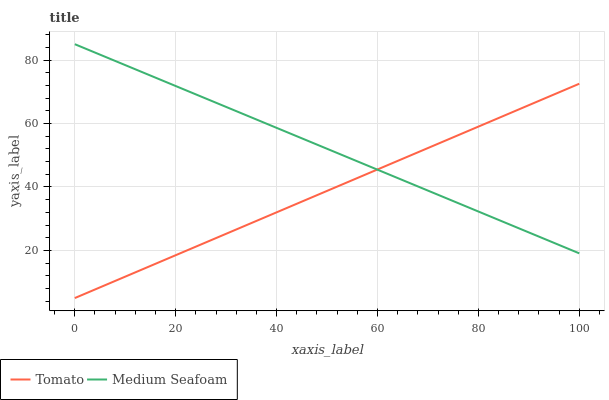Does Tomato have the minimum area under the curve?
Answer yes or no. Yes. Does Medium Seafoam have the maximum area under the curve?
Answer yes or no. Yes. Does Medium Seafoam have the minimum area under the curve?
Answer yes or no. No. Is Tomato the smoothest?
Answer yes or no. Yes. Is Medium Seafoam the roughest?
Answer yes or no. Yes. Is Medium Seafoam the smoothest?
Answer yes or no. No. Does Tomato have the lowest value?
Answer yes or no. Yes. Does Medium Seafoam have the lowest value?
Answer yes or no. No. Does Medium Seafoam have the highest value?
Answer yes or no. Yes. Does Tomato intersect Medium Seafoam?
Answer yes or no. Yes. Is Tomato less than Medium Seafoam?
Answer yes or no. No. Is Tomato greater than Medium Seafoam?
Answer yes or no. No. 